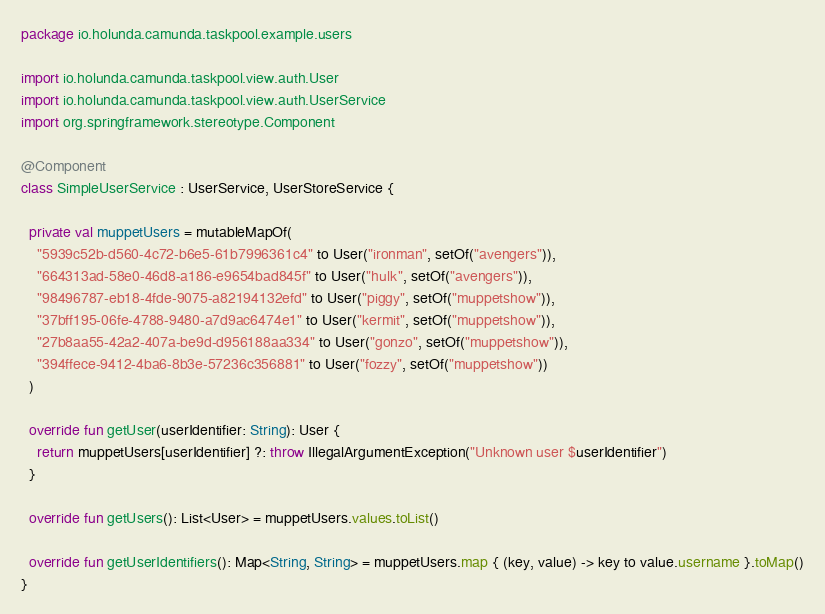Convert code to text. <code><loc_0><loc_0><loc_500><loc_500><_Kotlin_>package io.holunda.camunda.taskpool.example.users

import io.holunda.camunda.taskpool.view.auth.User
import io.holunda.camunda.taskpool.view.auth.UserService
import org.springframework.stereotype.Component

@Component
class SimpleUserService : UserService, UserStoreService {

  private val muppetUsers = mutableMapOf(
    "5939c52b-d560-4c72-b6e5-61b7996361c4" to User("ironman", setOf("avengers")),
    "664313ad-58e0-46d8-a186-e9654bad845f" to User("hulk", setOf("avengers")),
    "98496787-eb18-4fde-9075-a82194132efd" to User("piggy", setOf("muppetshow")),
    "37bff195-06fe-4788-9480-a7d9ac6474e1" to User("kermit", setOf("muppetshow")),
    "27b8aa55-42a2-407a-be9d-d956188aa334" to User("gonzo", setOf("muppetshow")),
    "394ffece-9412-4ba6-8b3e-57236c356881" to User("fozzy", setOf("muppetshow"))
  )

  override fun getUser(userIdentifier: String): User {
    return muppetUsers[userIdentifier] ?: throw IllegalArgumentException("Unknown user $userIdentifier")
  }

  override fun getUsers(): List<User> = muppetUsers.values.toList()

  override fun getUserIdentifiers(): Map<String, String> = muppetUsers.map { (key, value) -> key to value.username }.toMap()
}
</code> 